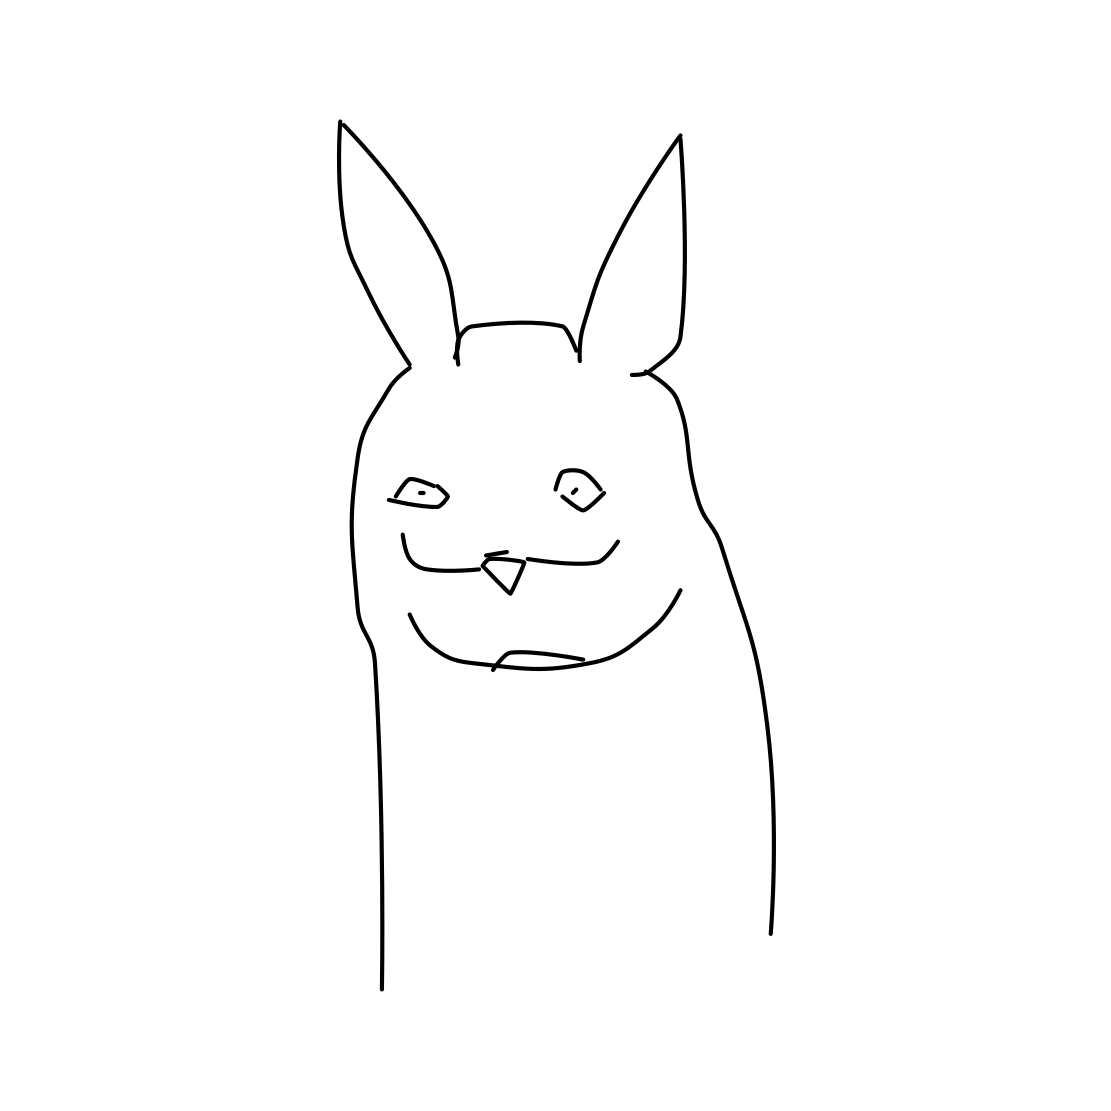What's the mood conveyed by the character in the drawing? The character in the drawing has a mischievous and playful expression, suggesting a light-hearted and humorous mood. 